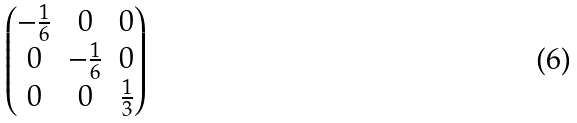<formula> <loc_0><loc_0><loc_500><loc_500>\begin{pmatrix} - \frac { 1 } { 6 } & 0 & 0 \\ 0 & - \frac { 1 } { 6 } & 0 \\ 0 & 0 & \frac { 1 } { 3 } \end{pmatrix}</formula> 